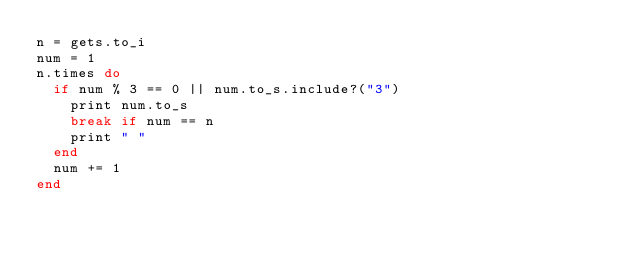<code> <loc_0><loc_0><loc_500><loc_500><_Ruby_>n = gets.to_i
num = 1
n.times do
  if num % 3 == 0 || num.to_s.include?("3")
    print num.to_s
    break if num == n
    print " "
  end
  num += 1
end

</code> 